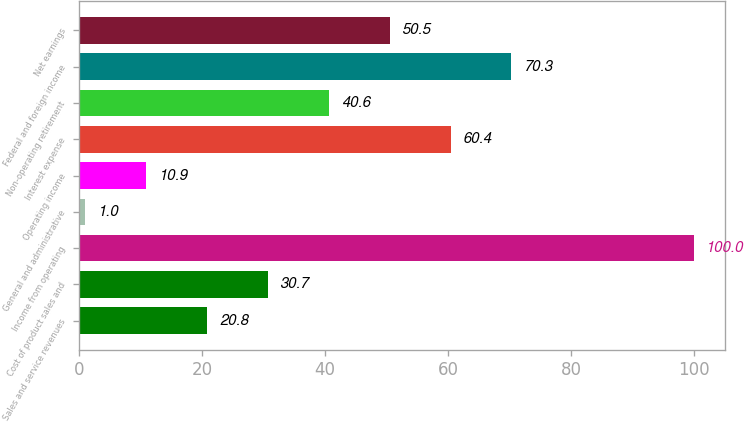Convert chart. <chart><loc_0><loc_0><loc_500><loc_500><bar_chart><fcel>Sales and service revenues<fcel>Cost of product sales and<fcel>Income from operating<fcel>General and administrative<fcel>Operating income<fcel>Interest expense<fcel>Non-operating retirement<fcel>Federal and foreign income<fcel>Net earnings<nl><fcel>20.8<fcel>30.7<fcel>100<fcel>1<fcel>10.9<fcel>60.4<fcel>40.6<fcel>70.3<fcel>50.5<nl></chart> 